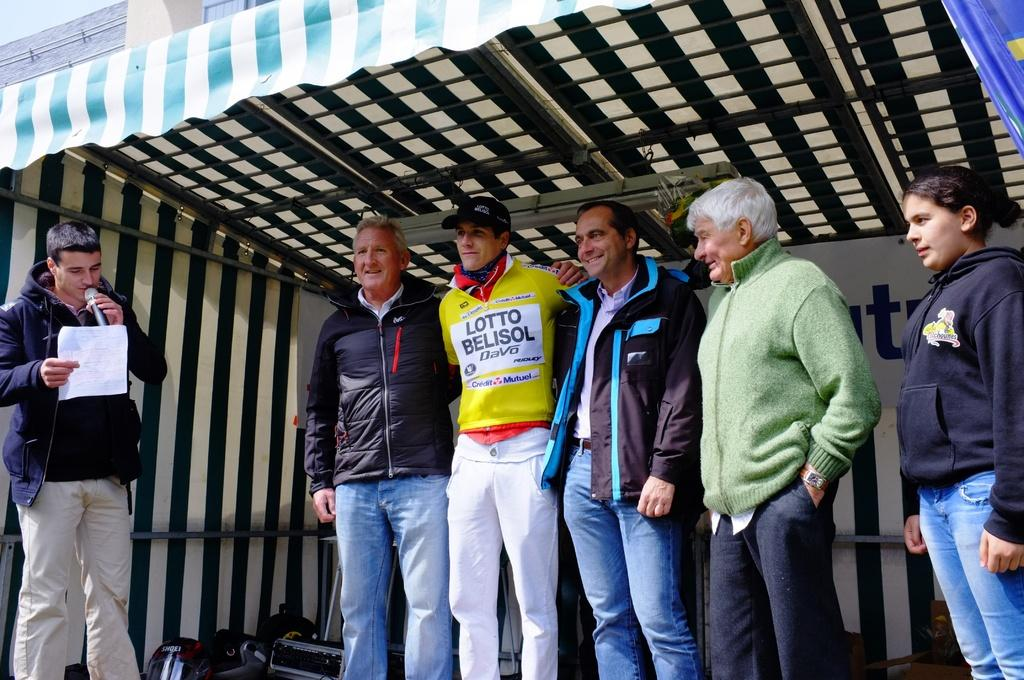<image>
Share a concise interpretation of the image provided. A man is wearing a Lotto Belisol chest sticker 